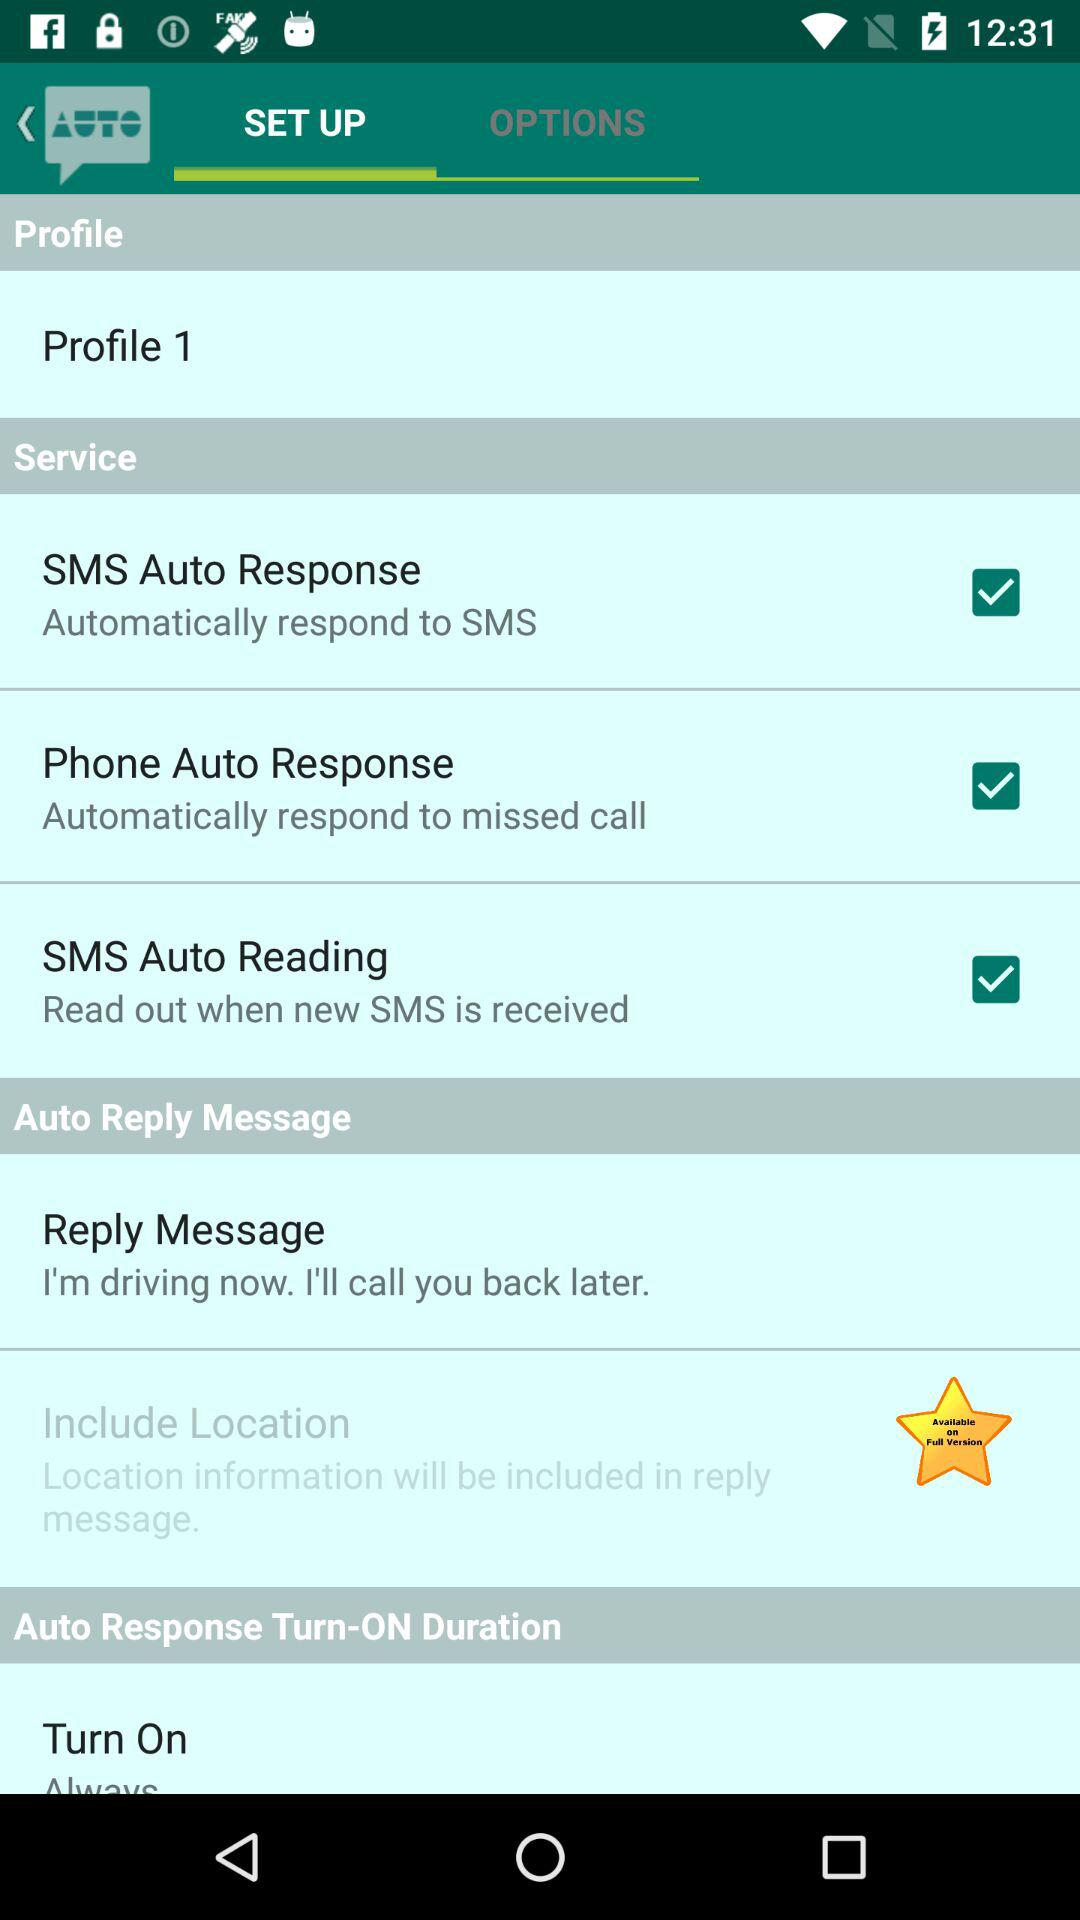What is the status of the "SMS Auto Reading" service? The status is "on". 